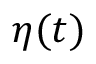<formula> <loc_0><loc_0><loc_500><loc_500>{ \eta } ( t )</formula> 